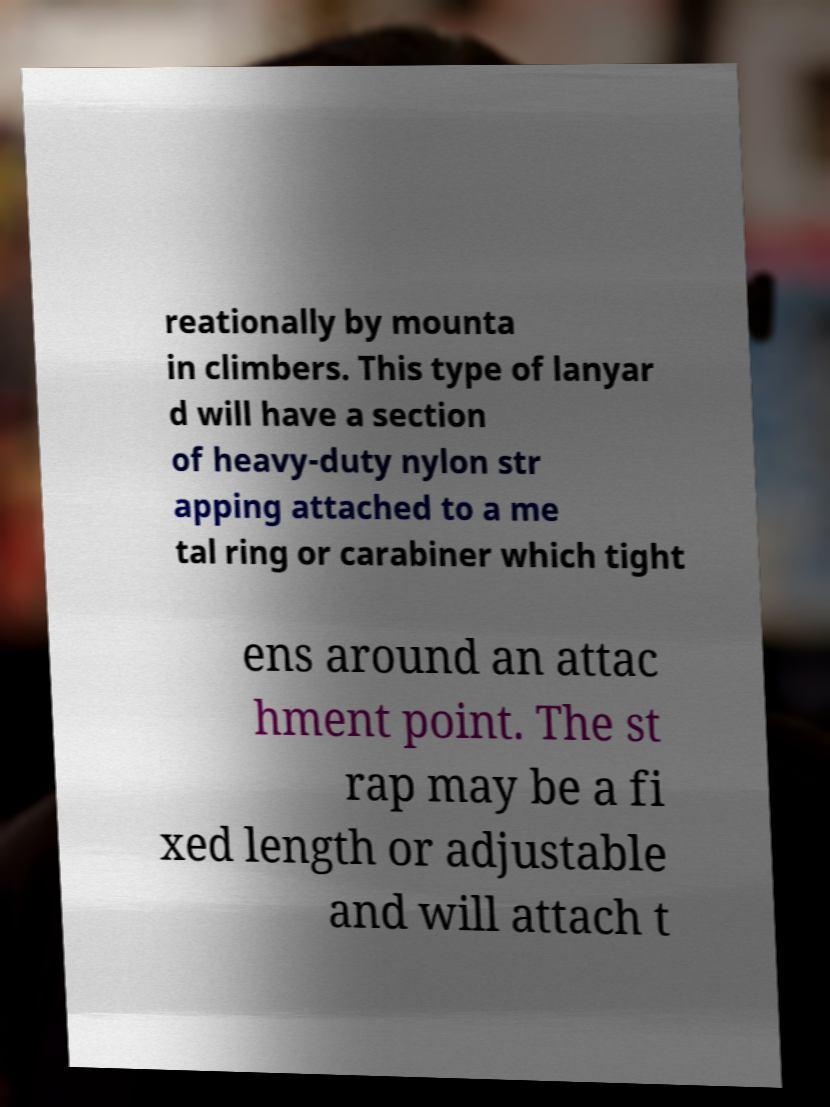Please read and relay the text visible in this image. What does it say? reationally by mounta in climbers. This type of lanyar d will have a section of heavy-duty nylon str apping attached to a me tal ring or carabiner which tight ens around an attac hment point. The st rap may be a fi xed length or adjustable and will attach t 